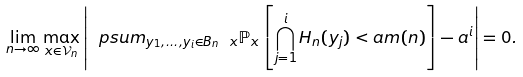Convert formula to latex. <formula><loc_0><loc_0><loc_500><loc_500>\lim _ { n \to \infty } \max _ { x \in \mathcal { V } _ { n } } \left | \ p s u m _ { y _ { 1 } , \dots , y _ { i } \in B _ { n } \ x } \mathbb { P } _ { x } \left [ \bigcap _ { j = 1 } ^ { i } H _ { n } ( y _ { j } ) < a m ( n ) \right ] - a ^ { i } \right | = 0 .</formula> 